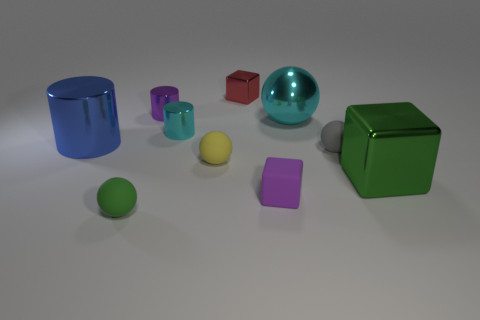Subtract all red spheres. Subtract all red cubes. How many spheres are left? 4 Subtract all cylinders. How many objects are left? 7 Add 3 tiny purple blocks. How many tiny purple blocks exist? 4 Subtract 1 cyan spheres. How many objects are left? 9 Subtract all shiny cubes. Subtract all small green metal balls. How many objects are left? 8 Add 9 big blue cylinders. How many big blue cylinders are left? 10 